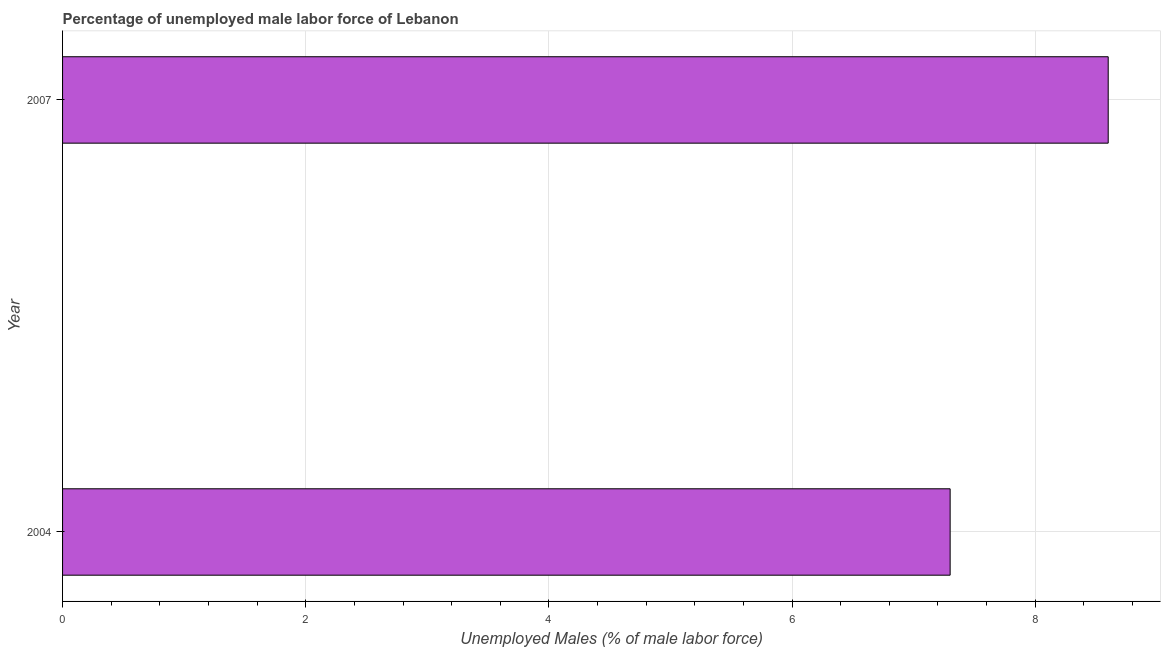Does the graph contain any zero values?
Your answer should be very brief. No. What is the title of the graph?
Your answer should be very brief. Percentage of unemployed male labor force of Lebanon. What is the label or title of the X-axis?
Your answer should be very brief. Unemployed Males (% of male labor force). What is the total unemployed male labour force in 2004?
Your response must be concise. 7.3. Across all years, what is the maximum total unemployed male labour force?
Offer a very short reply. 8.6. Across all years, what is the minimum total unemployed male labour force?
Keep it short and to the point. 7.3. In which year was the total unemployed male labour force maximum?
Offer a very short reply. 2007. What is the sum of the total unemployed male labour force?
Your answer should be very brief. 15.9. What is the difference between the total unemployed male labour force in 2004 and 2007?
Your response must be concise. -1.3. What is the average total unemployed male labour force per year?
Offer a terse response. 7.95. What is the median total unemployed male labour force?
Keep it short and to the point. 7.95. In how many years, is the total unemployed male labour force greater than 3.2 %?
Your response must be concise. 2. What is the ratio of the total unemployed male labour force in 2004 to that in 2007?
Keep it short and to the point. 0.85. In how many years, is the total unemployed male labour force greater than the average total unemployed male labour force taken over all years?
Your answer should be compact. 1. How many bars are there?
Keep it short and to the point. 2. Are all the bars in the graph horizontal?
Offer a very short reply. Yes. How many years are there in the graph?
Keep it short and to the point. 2. What is the difference between two consecutive major ticks on the X-axis?
Ensure brevity in your answer.  2. What is the Unemployed Males (% of male labor force) of 2004?
Offer a terse response. 7.3. What is the Unemployed Males (% of male labor force) in 2007?
Offer a terse response. 8.6. What is the difference between the Unemployed Males (% of male labor force) in 2004 and 2007?
Provide a short and direct response. -1.3. What is the ratio of the Unemployed Males (% of male labor force) in 2004 to that in 2007?
Your answer should be compact. 0.85. 